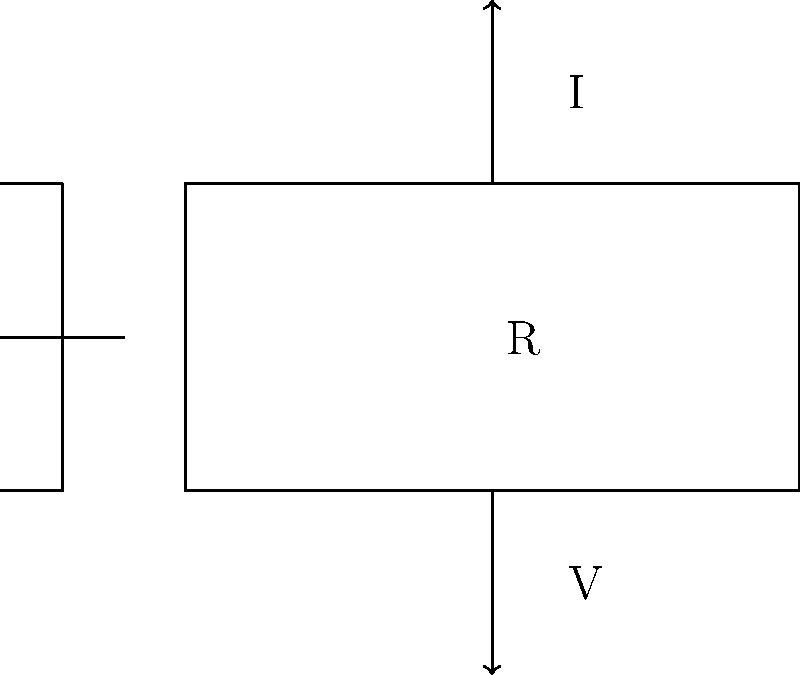In the given circuit diagram, identify the relationship between voltage (V), current (I), and resistance (R) according to Ohm's Law. Which equation correctly represents this relationship?

A) $V = IR$
B) $I = VR$
C) $R = VI$
D) $V = I/R$ To answer this question, let's break it down step-by-step:

1. Identify the components in the circuit:
   - We can see a resistor (R) in the middle of the circuit.
   - There's a voltage source (V) on the left side.
   - The current (I) is shown flowing through the circuit.

2. Recall Ohm's Law:
   - Ohm's Law states that the current through a conductor between two points is directly proportional to the voltage across the two points.

3. Express Ohm's Law mathematically:
   - The mathematical form of Ohm's Law is $V = IR$, where:
     V is the voltage across the conductor in volts
     I is the current through the conductor in amperes
     R is the resistance of the conductor in ohms

4. Analyze the given options:
   A) $V = IR$ : This matches the correct form of Ohm's Law.
   B) $I = VR$ : This is incorrect, as it would mean current increases with resistance, which is not true.
   C) $R = VI$ : This is incorrect, as resistance is not the product of voltage and current.
   D) $V = I/R$ : This is incorrect, as it suggests voltage decreases with increasing resistance, which is not true.

5. Choose the correct answer:
   The correct relationship is $V = IR$, which is option A.
Answer: A) $V = IR$ 